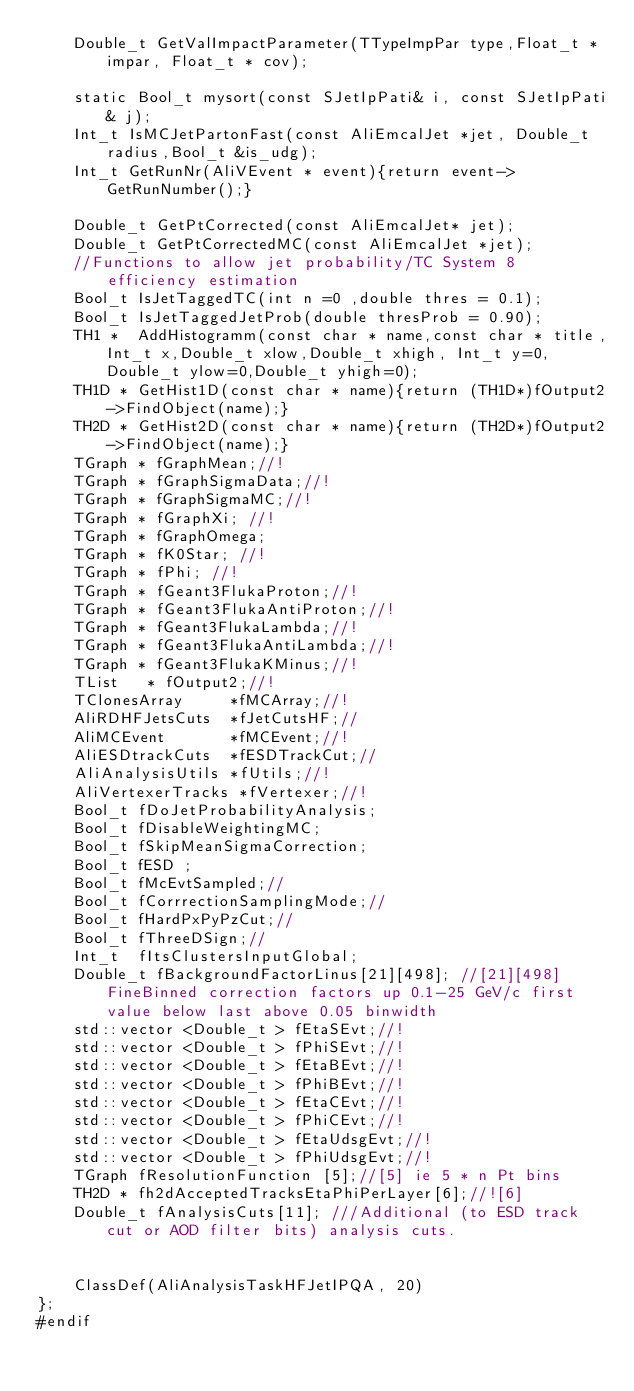Convert code to text. <code><loc_0><loc_0><loc_500><loc_500><_C_>    Double_t GetValImpactParameter(TTypeImpPar type,Float_t *impar, Float_t * cov);

    static Bool_t mysort(const SJetIpPati& i, const SJetIpPati& j);
    Int_t IsMCJetPartonFast(const AliEmcalJet *jet, Double_t radius,Bool_t &is_udg);
    Int_t GetRunNr(AliVEvent * event){return event->GetRunNumber();}

    Double_t GetPtCorrected(const AliEmcalJet* jet);
    Double_t GetPtCorrectedMC(const AliEmcalJet *jet);
    //Functions to allow jet probability/TC System 8 efficiency estimation
    Bool_t IsJetTaggedTC(int n =0 ,double thres = 0.1);
    Bool_t IsJetTaggedJetProb(double thresProb = 0.90);
    TH1 *  AddHistogramm(const char * name,const char * title,Int_t x,Double_t xlow,Double_t xhigh, Int_t y=0,Double_t ylow=0,Double_t yhigh=0);
    TH1D * GetHist1D(const char * name){return (TH1D*)fOutput2->FindObject(name);}
    TH2D * GetHist2D(const char * name){return (TH2D*)fOutput2->FindObject(name);}
    TGraph * fGraphMean;//!
    TGraph * fGraphSigmaData;//!
    TGraph * fGraphSigmaMC;//!
    TGraph * fGraphXi; //!
    TGraph * fGraphOmega;
    TGraph * fK0Star; //!
    TGraph * fPhi; //!
    TGraph * fGeant3FlukaProton;//!
    TGraph * fGeant3FlukaAntiProton;//!
    TGraph * fGeant3FlukaLambda;//!
    TGraph * fGeant3FlukaAntiLambda;//!
    TGraph * fGeant3FlukaKMinus;//!
    TList   * fOutput2;//!
    TClonesArray     *fMCArray;//!
    AliRDHFJetsCuts  *fJetCutsHF;//
    AliMCEvent       *fMCEvent;//!
    AliESDtrackCuts  *fESDTrackCut;//
    AliAnalysisUtils *fUtils;//!
    AliVertexerTracks *fVertexer;//!
    Bool_t fDoJetProbabilityAnalysis;
    Bool_t fDisableWeightingMC;
    Bool_t fSkipMeanSigmaCorrection;
    Bool_t fESD ;
    Bool_t fMcEvtSampled;//
    Bool_t fCorrrectionSamplingMode;//
    Bool_t fHardPxPyPzCut;//
    Bool_t fThreeDSign;//
    Int_t  fItsClustersInputGlobal;
    Double_t fBackgroundFactorLinus[21][498]; //[21][498]FineBinned correction factors up 0.1-25 GeV/c first value below last above 0.05 binwidth
    std::vector <Double_t > fEtaSEvt;//!
    std::vector <Double_t > fPhiSEvt;//!
    std::vector <Double_t > fEtaBEvt;//!
    std::vector <Double_t > fPhiBEvt;//!
    std::vector <Double_t > fEtaCEvt;//!
    std::vector <Double_t > fPhiCEvt;//!
    std::vector <Double_t > fEtaUdsgEvt;//!
    std::vector <Double_t > fPhiUdsgEvt;//!
    TGraph fResolutionFunction [5];//[5] ie 5 * n Pt bins
    TH2D * fh2dAcceptedTracksEtaPhiPerLayer[6];//![6]
    Double_t fAnalysisCuts[11]; ///Additional (to ESD track cut or AOD filter bits) analysis cuts.


    ClassDef(AliAnalysisTaskHFJetIPQA, 20)
};
#endif


</code> 